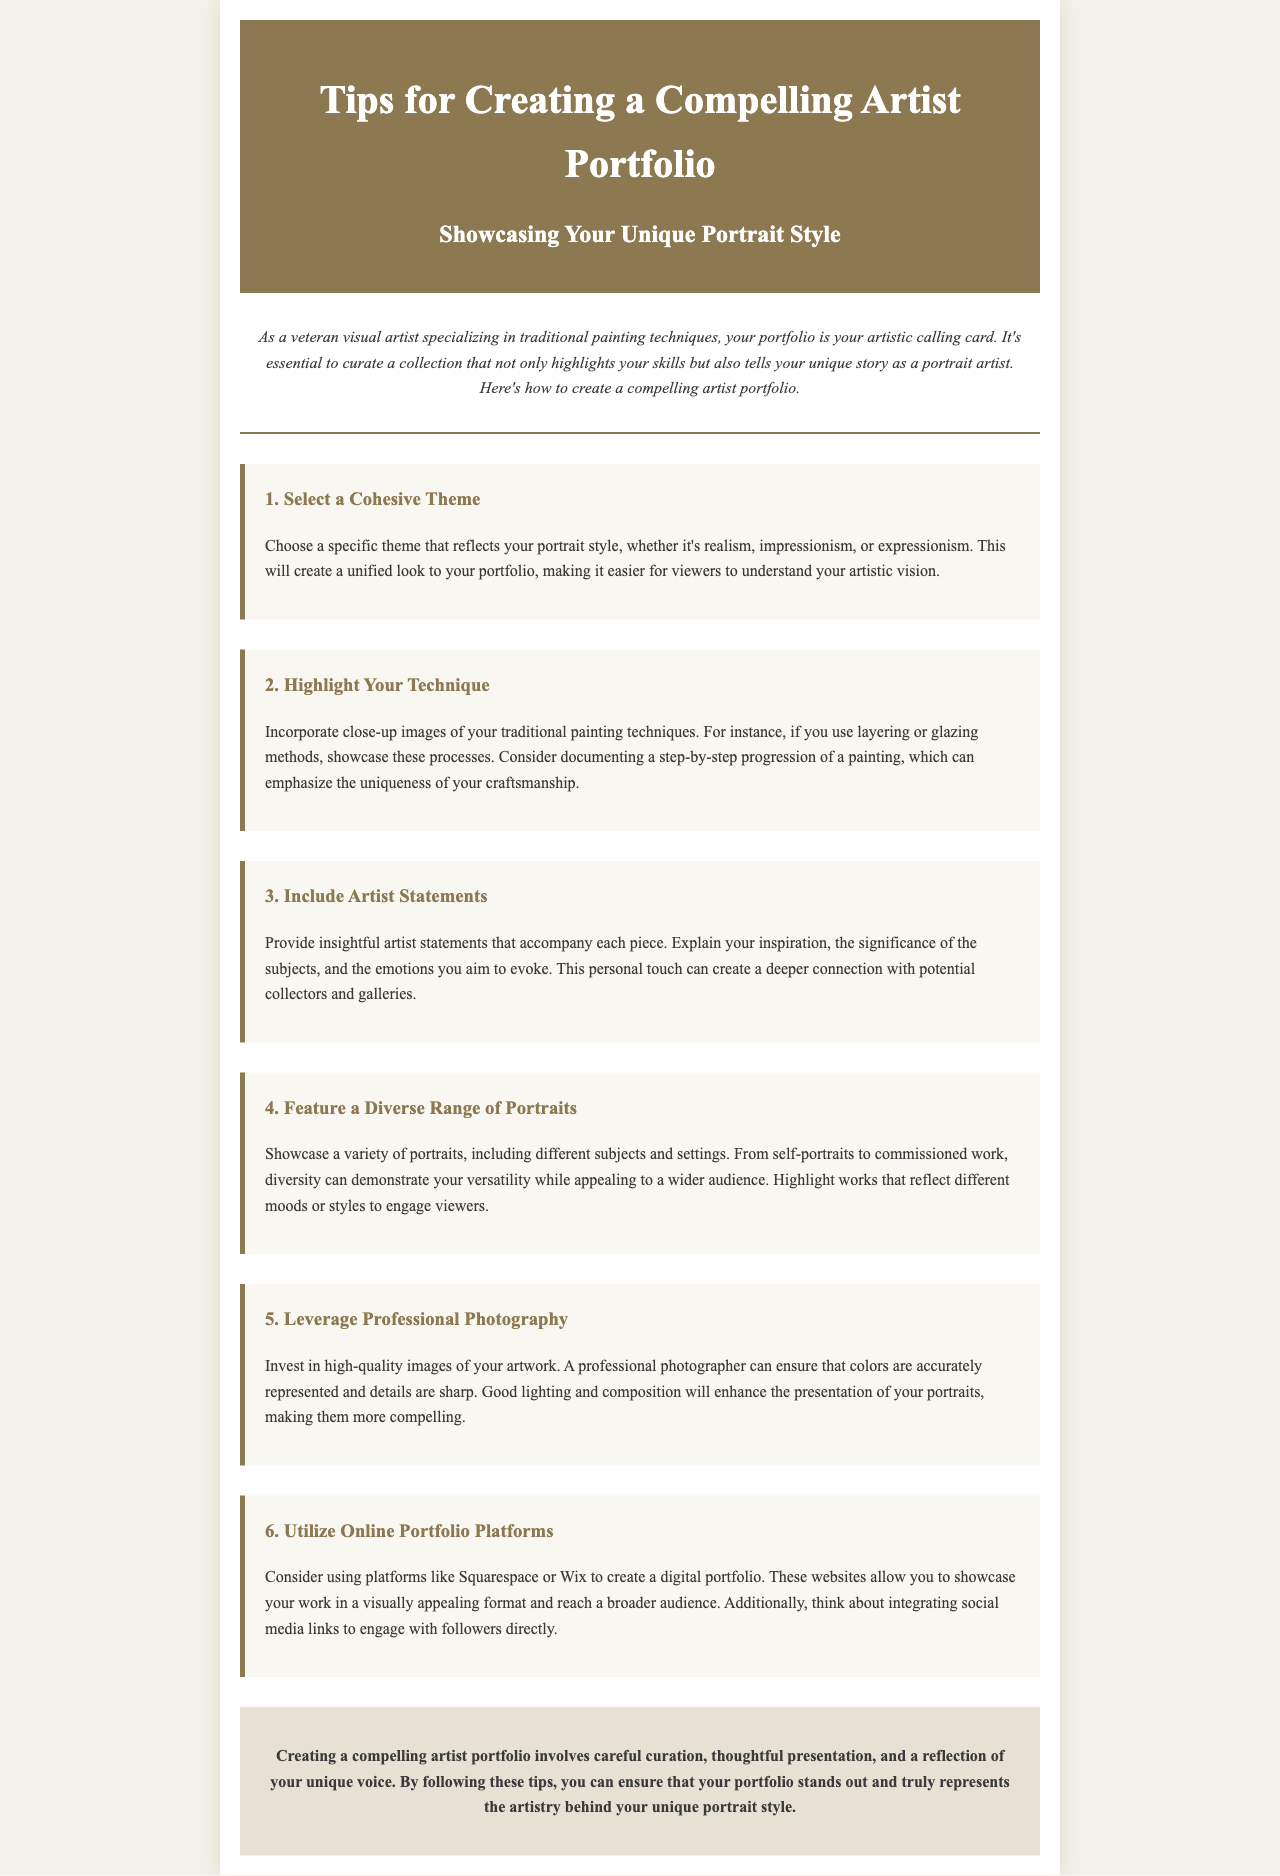What is the main focus of the newsletter? The newsletter focuses on tips for creating a compelling artist portfolio specific to portrait artists.
Answer: Tips for Creating a Compelling Artist Portfolio How many tips are provided in the newsletter? The newsletter enumerates six specific tips for artists.
Answer: 6 What should be highlighted according to tip 2? Tip 2 emphasizes showcasing close-up images of traditional painting techniques.
Answer: Traditional painting techniques Which platforms are suggested for creating a digital portfolio? The newsletter recommends platforms like Squarespace or Wix for digital portfolios.
Answer: Squarespace or Wix What type of statements should accompany each piece in the portfolio? Artist statements should provide insights into the inspiration and significance of the subjects.
Answer: Artist statements Why is professional photography recommended? High-quality images ensure accurate color representation and sharp details for artwork presentation.
Answer: Accurate color representation and sharp details What aspect of diversity is encouraged in tip 4? Tip 4 encourages showcasing a variety of portraits, including different subjects and settings.
Answer: Different subjects and settings What should the conclusion of the newsletter highlight? The conclusion emphasizes careful curation and thoughtful presentation of the portfolio.
Answer: Careful curation and thoughtful presentation 